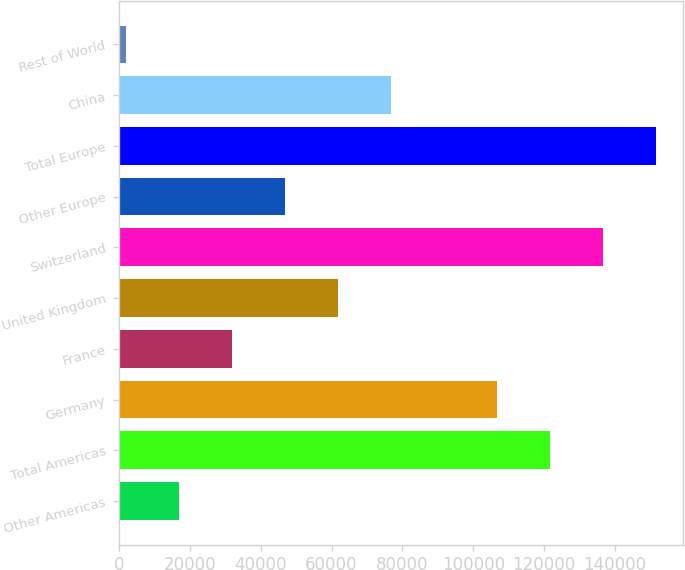Convert chart to OTSL. <chart><loc_0><loc_0><loc_500><loc_500><bar_chart><fcel>Other Americas<fcel>Total Americas<fcel>Germany<fcel>France<fcel>United Kingdom<fcel>Switzerland<fcel>Other Europe<fcel>Total Europe<fcel>China<fcel>Rest of World<nl><fcel>17024.1<fcel>121703<fcel>106749<fcel>31978.2<fcel>61886.4<fcel>136657<fcel>46932.3<fcel>151611<fcel>76840.5<fcel>2070<nl></chart> 